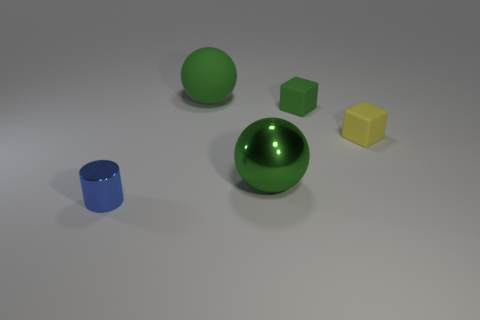If I were to touch the yellow cube, what texture do you think it would have based on its appearance? Based on its appearance, the yellow cube might have a slightly rough texture, as it does not display distinct reflections or shine that would suggest a smooth surface. 